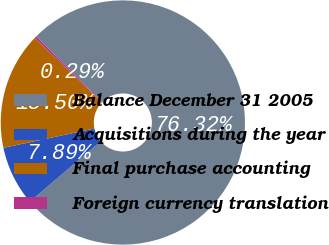<chart> <loc_0><loc_0><loc_500><loc_500><pie_chart><fcel>Balance December 31 2005<fcel>Acquisitions during the year<fcel>Final purchase accounting<fcel>Foreign currency translation<nl><fcel>76.33%<fcel>7.89%<fcel>15.5%<fcel>0.29%<nl></chart> 